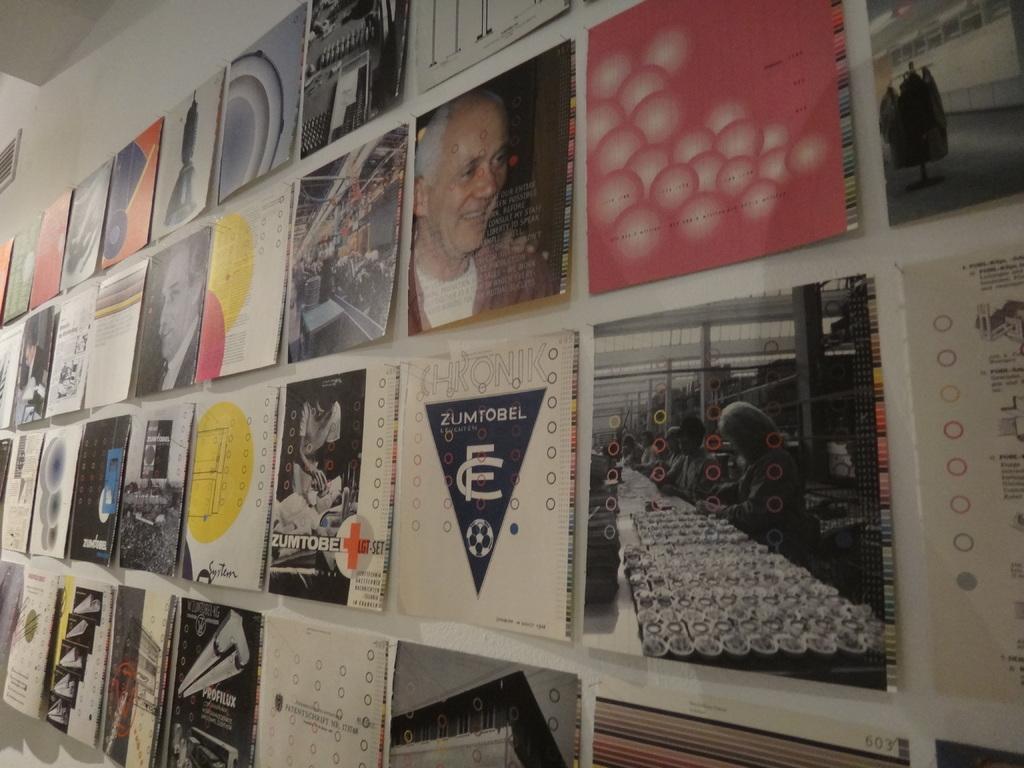Do one of these say zumtobel?
Offer a terse response. Yes. 